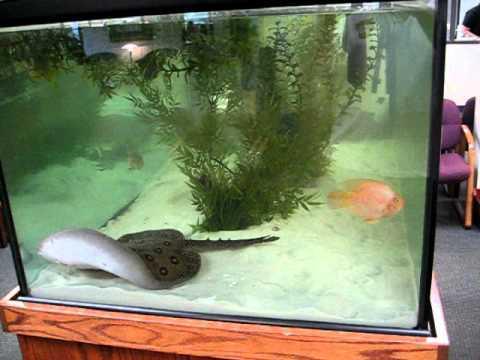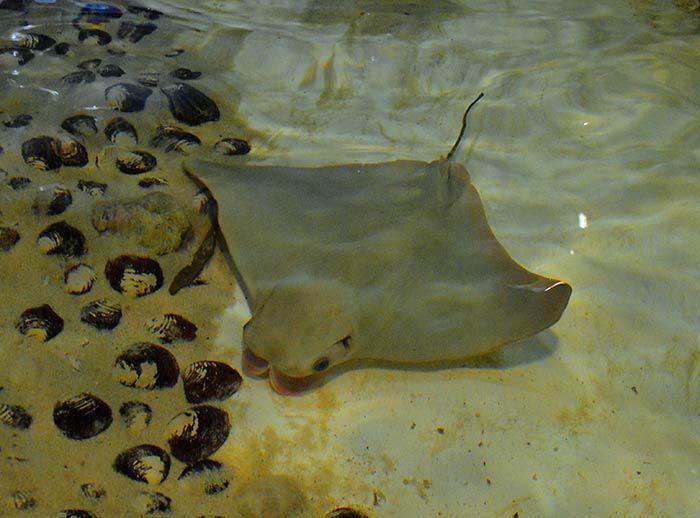The first image is the image on the left, the second image is the image on the right. Assess this claim about the two images: "In the left image, a fish is visible in the tank with a sting ray.". Correct or not? Answer yes or no. Yes. 